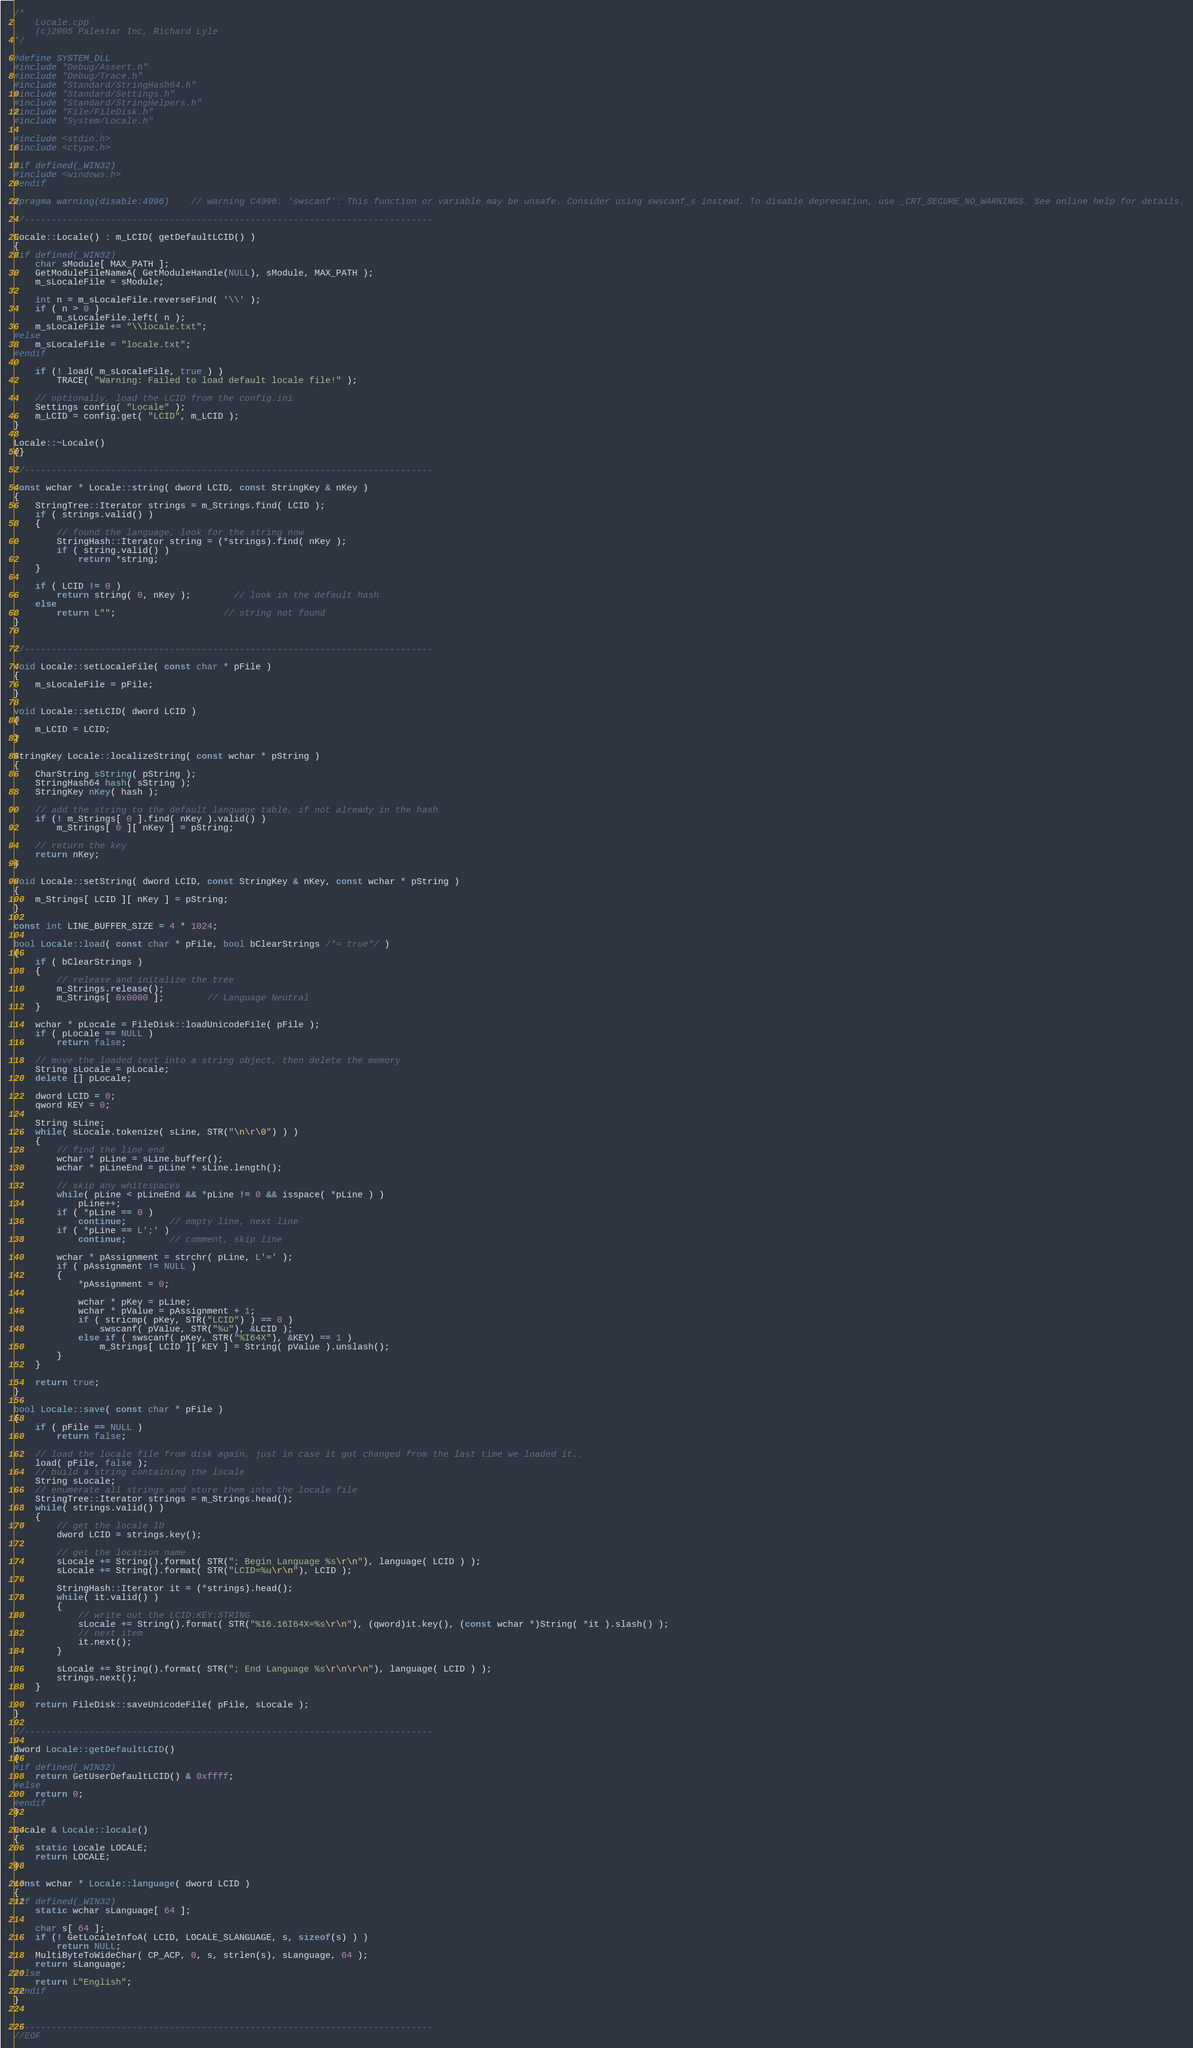<code> <loc_0><loc_0><loc_500><loc_500><_C++_>/*
	Locale.cpp
	(c)2005 Palestar Inc, Richard Lyle
*/

#define SYSTEM_DLL
#include "Debug/Assert.h"
#include "Debug/Trace.h"
#include "Standard/StringHash64.h"
#include "Standard/Settings.h"
#include "Standard/StringHelpers.h"
#include "File/FileDisk.h"
#include "System/Locale.h"

#include <stdio.h>
#include <ctype.h>

#if defined(_WIN32)
#include <windows.h>
#endif

#pragma warning(disable:4996)	// warning C4996: 'swscanf': This function or variable may be unsafe. Consider using swscanf_s instead. To disable deprecation, use _CRT_SECURE_NO_WARNINGS. See online help for details.

//----------------------------------------------------------------------------

Locale::Locale() : m_LCID( getDefaultLCID() )
{
#if defined(_WIN32)
	char sModule[ MAX_PATH ];
	GetModuleFileNameA( GetModuleHandle(NULL), sModule, MAX_PATH );
	m_sLocaleFile = sModule;

	int n = m_sLocaleFile.reverseFind( '\\' );
	if ( n > 0 )
		m_sLocaleFile.left( n );
	m_sLocaleFile += "\\locale.txt";
#else
	m_sLocaleFile = "locale.txt";
#endif

	if (! load( m_sLocaleFile, true ) )
		TRACE( "Warning: Failed to load default locale file!" );

	// optionally, load the LCID from the config.ini
	Settings config( "Locale" );
	m_LCID = config.get( "LCID", m_LCID );
}

Locale::~Locale()
{}

//----------------------------------------------------------------------------

const wchar * Locale::string( dword LCID, const StringKey & nKey ) 
{
	StringTree::Iterator strings = m_Strings.find( LCID );
	if ( strings.valid() )
	{
		// found the language, look for the string now
		StringHash::Iterator string = (*strings).find( nKey );
		if ( string.valid() )
			return *string;
	}

	if ( LCID != 0 )
		return string( 0, nKey );		// look in the default hash
	else
		return L"";					// string not found
}


//----------------------------------------------------------------------------

void Locale::setLocaleFile( const char * pFile )
{
	m_sLocaleFile = pFile;
}

void Locale::setLCID( dword LCID )
{
	m_LCID = LCID;
}

StringKey Locale::localizeString( const wchar * pString )
{
	CharString sString( pString );
	StringHash64 hash( sString );
	StringKey nKey( hash );

	// add the string to the default language table, if not already in the hash
	if (! m_Strings[ 0 ].find( nKey ).valid() )
		m_Strings[ 0 ][ nKey ] = pString;

	// return the key
	return nKey;
}

void Locale::setString( dword LCID, const StringKey & nKey, const wchar * pString )
{
	m_Strings[ LCID ][ nKey ] = pString;
}

const int LINE_BUFFER_SIZE = 4 * 1024;

bool Locale::load( const char * pFile, bool bClearStrings /*= true*/ )
{
	if ( bClearStrings )
	{
		// release and initalize the tree
		m_Strings.release();
		m_Strings[ 0x0000 ];		// Language Neutral
	}

	wchar * pLocale = FileDisk::loadUnicodeFile( pFile );
	if ( pLocale == NULL )
		return false;

	// move the loaded text into a string object, then delete the memory
	String sLocale = pLocale;
	delete [] pLocale;

	dword LCID = 0;
	qword KEY = 0;

	String sLine;
	while( sLocale.tokenize( sLine, STR("\n\r\0") ) )
	{
		// find the line end
		wchar * pLine = sLine.buffer();
		wchar * pLineEnd = pLine + sLine.length();

		// skip any whitespaces
		while( pLine < pLineEnd && *pLine != 0 && isspace( *pLine ) )
			pLine++;
		if ( *pLine == 0 )
			continue;		// empty line, next line
		if ( *pLine == L';' )
			continue;		// comment, skip line
		
		wchar * pAssignment = strchr( pLine, L'=' );
		if ( pAssignment != NULL )
		{
			*pAssignment = 0;

			wchar * pKey = pLine;
			wchar * pValue = pAssignment + 1;
			if ( stricmp( pKey, STR("LCID") ) == 0 )
				swscanf( pValue, STR("%u"), &LCID );
			else if ( swscanf( pKey, STR("%I64X"), &KEY) == 1 )
				m_Strings[ LCID ][ KEY ] = String( pValue ).unslash();
		}
	}

	return true;
}

bool Locale::save( const char * pFile )
{
	if ( pFile == NULL )
		return false;

	// load the locale file from disk again, just in case it got changed from the last time we loaded it..
	load( pFile, false );
	// build a string containing the locale
	String sLocale;
	// enumerate all strings and store them into the locale file
	StringTree::Iterator strings = m_Strings.head();
	while( strings.valid() )
	{
		// get the locale ID
		dword LCID = strings.key();

		// get the location name
		sLocale += String().format( STR("; Begin Language %s\r\n"), language( LCID ) );
		sLocale += String().format( STR("LCID=%u\r\n"), LCID );

		StringHash::Iterator it = (*strings).head();
		while( it.valid() )
		{
			// write out the LCID:KEY:STRING
			sLocale += String().format( STR("%16.16I64X=%s\r\n"), (qword)it.key(), (const wchar *)String( *it ).slash() );
			// next item
			it.next();
		}

		sLocale += String().format( STR("; End Language %s\r\n\r\n"), language( LCID ) );
		strings.next();
	}

	return FileDisk::saveUnicodeFile( pFile, sLocale );
}

//----------------------------------------------------------------------------

dword Locale::getDefaultLCID()
{
#if defined(_WIN32)
	return GetUserDefaultLCID() & 0xffff;
#else
	return 0;
#endif
}

Locale & Locale::locale()
{
	static Locale LOCALE;
	return LOCALE;
}

const wchar * Locale::language( dword LCID )
{
#if defined(_WIN32)
	static wchar sLanguage[ 64 ];

	char s[ 64 ];
	if (! GetLocaleInfoA( LCID, LOCALE_SLANGUAGE, s, sizeof(s) ) )
		return NULL;
	MultiByteToWideChar( CP_ACP, 0, s, strlen(s), sLanguage, 64 );
	return sLanguage;
#else
	return L"English";
#endif
}


//----------------------------------------------------------------------------
//EOF
</code> 